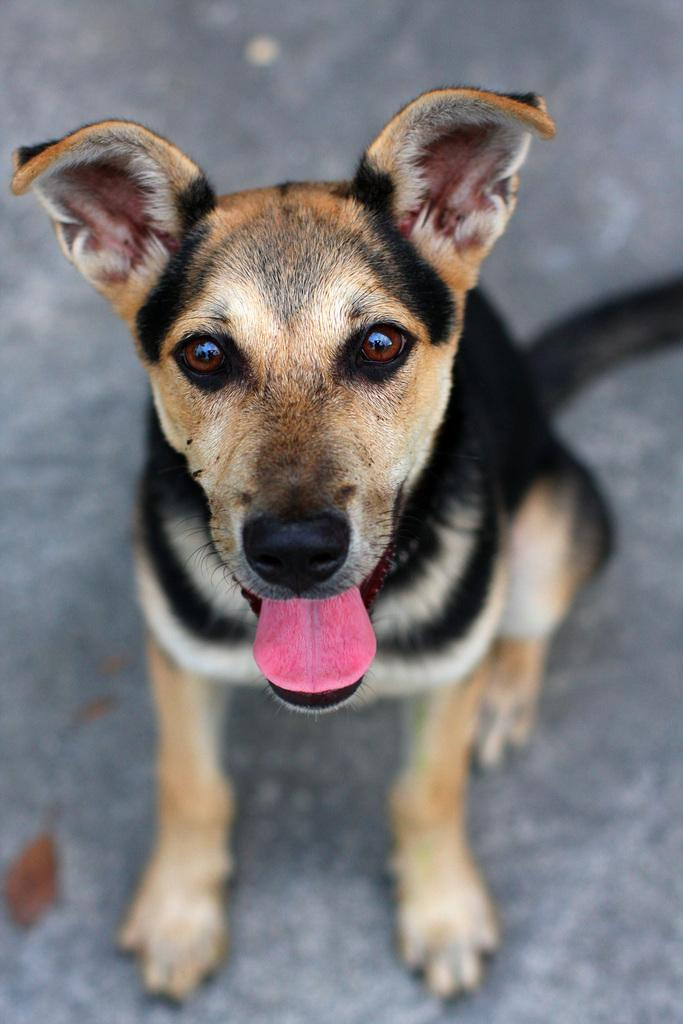What animal is in the image? There is a dog in the image. Where is the dog located in the image? The dog is in the center of the image. What colors can be seen on the dog? The dog is black and brown in color. What songs can be heard playing in the background of the image? There is no audio or background music present in the image, so it is not possible to determine what songs might be heard. 